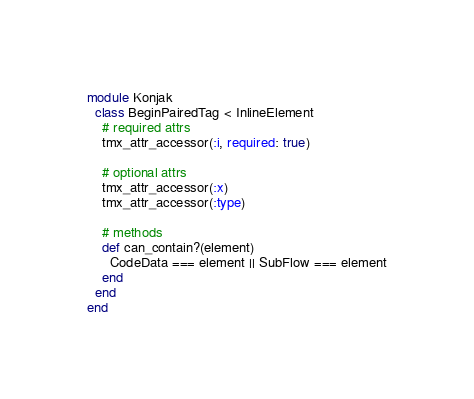<code> <loc_0><loc_0><loc_500><loc_500><_Ruby_>module Konjak
  class BeginPairedTag < InlineElement
    # required attrs
    tmx_attr_accessor(:i, required: true)

    # optional attrs
    tmx_attr_accessor(:x)
    tmx_attr_accessor(:type)

    # methods
    def can_contain?(element)
      CodeData === element || SubFlow === element
    end
  end
end
</code> 